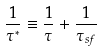<formula> <loc_0><loc_0><loc_500><loc_500>\frac { 1 } { \tau ^ { * } } \equiv \frac { 1 } { \tau } + \frac { 1 } { \tau _ { s f } }</formula> 